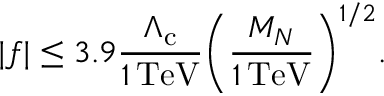<formula> <loc_0><loc_0><loc_500><loc_500>| f | \leq 3 . 9 \frac { \Lambda _ { c } } { 1 \, T e V } \left ( \frac { M _ { N } } { 1 \, T e V } \right ) ^ { 1 / 2 } .</formula> 